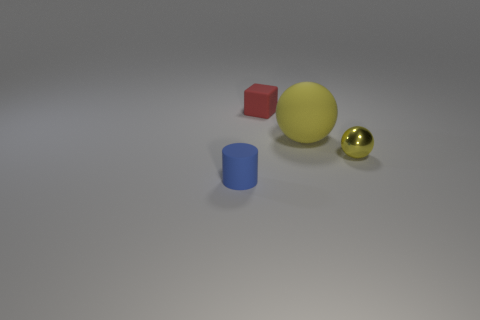What size is the thing that is in front of the tiny object that is right of the tiny matte object on the right side of the blue matte cylinder?
Your answer should be very brief. Small. Are there any large yellow balls that have the same material as the large yellow thing?
Your answer should be very brief. No. What shape is the blue matte object?
Offer a terse response. Cylinder. What is the color of the cylinder that is the same material as the block?
Provide a short and direct response. Blue. What number of red things are big metal cylinders or large matte spheres?
Your answer should be compact. 0. Are there more tiny red things than tiny brown balls?
Provide a short and direct response. Yes. How many things are either tiny rubber objects that are in front of the yellow matte object or tiny rubber cylinders in front of the tiny cube?
Keep it short and to the point. 1. There is a rubber object that is the same size as the red block; what is its color?
Offer a very short reply. Blue. Is the material of the blue cylinder the same as the tiny yellow sphere?
Your answer should be compact. No. There is a small thing left of the tiny rubber thing that is on the right side of the tiny blue cylinder; what is its material?
Keep it short and to the point. Rubber. 